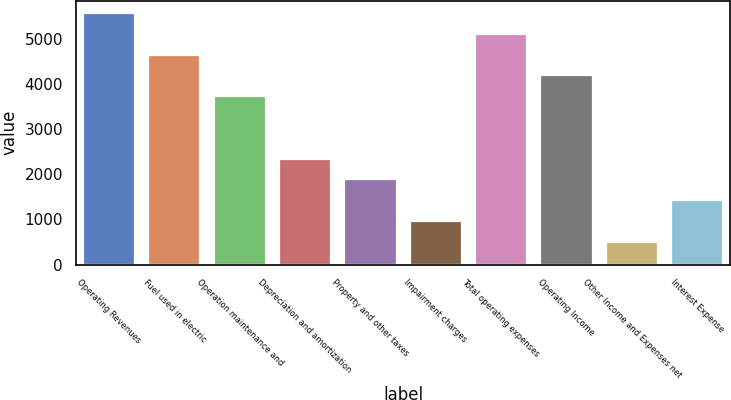Convert chart to OTSL. <chart><loc_0><loc_0><loc_500><loc_500><bar_chart><fcel>Operating Revenues<fcel>Fuel used in electric<fcel>Operation maintenance and<fcel>Depreciation and amortization<fcel>Property and other taxes<fcel>Impairment charges<fcel>Total operating expenses<fcel>Operating Income<fcel>Other Income and Expenses net<fcel>Interest Expense<nl><fcel>5566<fcel>4646<fcel>3726<fcel>2346<fcel>1886<fcel>966<fcel>5106<fcel>4186<fcel>506<fcel>1426<nl></chart> 